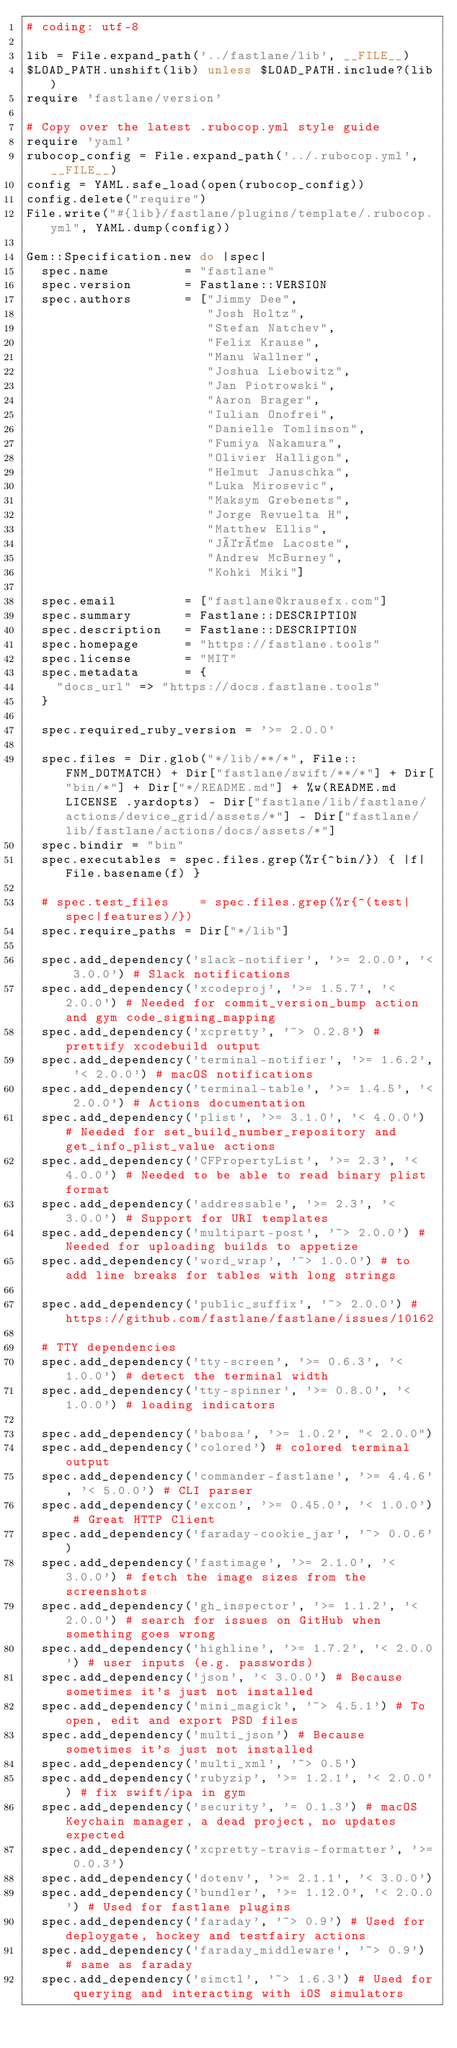Convert code to text. <code><loc_0><loc_0><loc_500><loc_500><_Ruby_># coding: utf-8

lib = File.expand_path('../fastlane/lib', __FILE__)
$LOAD_PATH.unshift(lib) unless $LOAD_PATH.include?(lib)
require 'fastlane/version'

# Copy over the latest .rubocop.yml style guide
require 'yaml'
rubocop_config = File.expand_path('../.rubocop.yml', __FILE__)
config = YAML.safe_load(open(rubocop_config))
config.delete("require")
File.write("#{lib}/fastlane/plugins/template/.rubocop.yml", YAML.dump(config))

Gem::Specification.new do |spec|
  spec.name          = "fastlane"
  spec.version       = Fastlane::VERSION
  spec.authors       = ["Jimmy Dee",
                        "Josh Holtz",
                        "Stefan Natchev",
                        "Felix Krause",
                        "Manu Wallner",
                        "Joshua Liebowitz",
                        "Jan Piotrowski",
                        "Aaron Brager",
                        "Iulian Onofrei",
                        "Danielle Tomlinson",
                        "Fumiya Nakamura",
                        "Olivier Halligon",
                        "Helmut Januschka",
                        "Luka Mirosevic",
                        "Maksym Grebenets",
                        "Jorge Revuelta H",
                        "Matthew Ellis",
                        "Jérôme Lacoste",
                        "Andrew McBurney",
                        "Kohki Miki"]

  spec.email         = ["fastlane@krausefx.com"]
  spec.summary       = Fastlane::DESCRIPTION
  spec.description   = Fastlane::DESCRIPTION
  spec.homepage      = "https://fastlane.tools"
  spec.license       = "MIT"
  spec.metadata      = {
    "docs_url" => "https://docs.fastlane.tools"
  }

  spec.required_ruby_version = '>= 2.0.0'

  spec.files = Dir.glob("*/lib/**/*", File::FNM_DOTMATCH) + Dir["fastlane/swift/**/*"] + Dir["bin/*"] + Dir["*/README.md"] + %w(README.md LICENSE .yardopts) - Dir["fastlane/lib/fastlane/actions/device_grid/assets/*"] - Dir["fastlane/lib/fastlane/actions/docs/assets/*"]
  spec.bindir = "bin"
  spec.executables = spec.files.grep(%r{^bin/}) { |f| File.basename(f) }

  # spec.test_files    = spec.files.grep(%r{^(test|spec|features)/})
  spec.require_paths = Dir["*/lib"]

  spec.add_dependency('slack-notifier', '>= 2.0.0', '< 3.0.0') # Slack notifications
  spec.add_dependency('xcodeproj', '>= 1.5.7', '< 2.0.0') # Needed for commit_version_bump action and gym code_signing_mapping
  spec.add_dependency('xcpretty', '~> 0.2.8') # prettify xcodebuild output
  spec.add_dependency('terminal-notifier', '>= 1.6.2', '< 2.0.0') # macOS notifications
  spec.add_dependency('terminal-table', '>= 1.4.5', '< 2.0.0') # Actions documentation
  spec.add_dependency('plist', '>= 3.1.0', '< 4.0.0') # Needed for set_build_number_repository and get_info_plist_value actions
  spec.add_dependency('CFPropertyList', '>= 2.3', '< 4.0.0') # Needed to be able to read binary plist format
  spec.add_dependency('addressable', '>= 2.3', '< 3.0.0') # Support for URI templates
  spec.add_dependency('multipart-post', '~> 2.0.0') # Needed for uploading builds to appetize
  spec.add_dependency('word_wrap', '~> 1.0.0') # to add line breaks for tables with long strings

  spec.add_dependency('public_suffix', '~> 2.0.0') # https://github.com/fastlane/fastlane/issues/10162

  # TTY dependencies
  spec.add_dependency('tty-screen', '>= 0.6.3', '< 1.0.0') # detect the terminal width
  spec.add_dependency('tty-spinner', '>= 0.8.0', '< 1.0.0') # loading indicators

  spec.add_dependency('babosa', '>= 1.0.2', "< 2.0.0")
  spec.add_dependency('colored') # colored terminal output
  spec.add_dependency('commander-fastlane', '>= 4.4.6', '< 5.0.0') # CLI parser
  spec.add_dependency('excon', '>= 0.45.0', '< 1.0.0') # Great HTTP Client
  spec.add_dependency('faraday-cookie_jar', '~> 0.0.6')
  spec.add_dependency('fastimage', '>= 2.1.0', '< 3.0.0') # fetch the image sizes from the screenshots
  spec.add_dependency('gh_inspector', '>= 1.1.2', '< 2.0.0') # search for issues on GitHub when something goes wrong
  spec.add_dependency('highline', '>= 1.7.2', '< 2.0.0') # user inputs (e.g. passwords)
  spec.add_dependency('json', '< 3.0.0') # Because sometimes it's just not installed
  spec.add_dependency('mini_magick', '~> 4.5.1') # To open, edit and export PSD files
  spec.add_dependency('multi_json') # Because sometimes it's just not installed
  spec.add_dependency('multi_xml', '~> 0.5')
  spec.add_dependency('rubyzip', '>= 1.2.1', '< 2.0.0') # fix swift/ipa in gym
  spec.add_dependency('security', '= 0.1.3') # macOS Keychain manager, a dead project, no updates expected
  spec.add_dependency('xcpretty-travis-formatter', '>= 0.0.3')
  spec.add_dependency('dotenv', '>= 2.1.1', '< 3.0.0')
  spec.add_dependency('bundler', '>= 1.12.0', '< 2.0.0') # Used for fastlane plugins
  spec.add_dependency('faraday', '~> 0.9') # Used for deploygate, hockey and testfairy actions
  spec.add_dependency('faraday_middleware', '~> 0.9') # same as faraday
  spec.add_dependency('simctl', '~> 1.6.3') # Used for querying and interacting with iOS simulators
</code> 